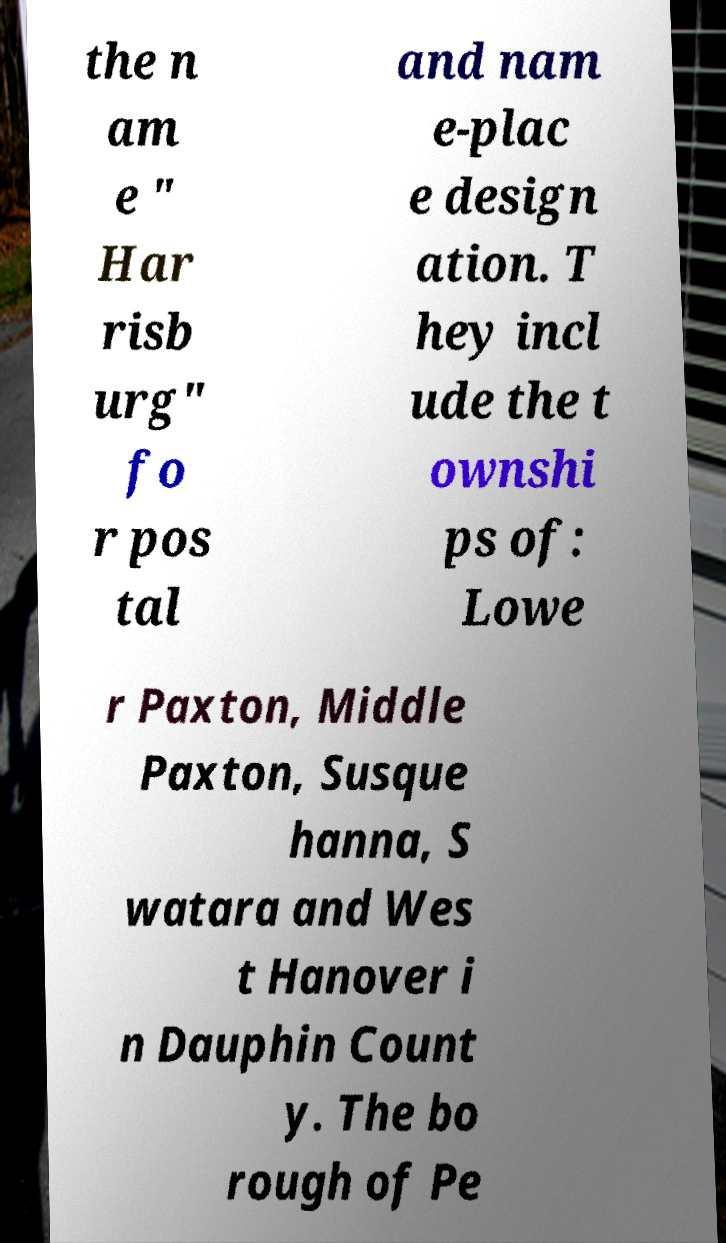For documentation purposes, I need the text within this image transcribed. Could you provide that? the n am e " Har risb urg" fo r pos tal and nam e-plac e design ation. T hey incl ude the t ownshi ps of: Lowe r Paxton, Middle Paxton, Susque hanna, S watara and Wes t Hanover i n Dauphin Count y. The bo rough of Pe 